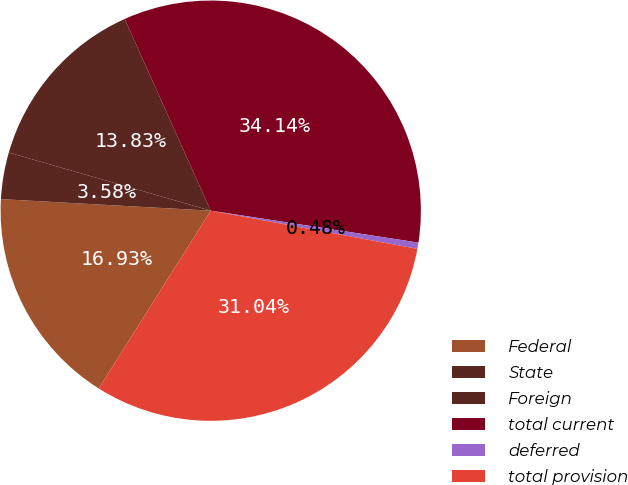Convert chart to OTSL. <chart><loc_0><loc_0><loc_500><loc_500><pie_chart><fcel>Federal<fcel>State<fcel>Foreign<fcel>total current<fcel>deferred<fcel>total provision<nl><fcel>16.93%<fcel>3.58%<fcel>13.83%<fcel>34.14%<fcel>0.48%<fcel>31.04%<nl></chart> 